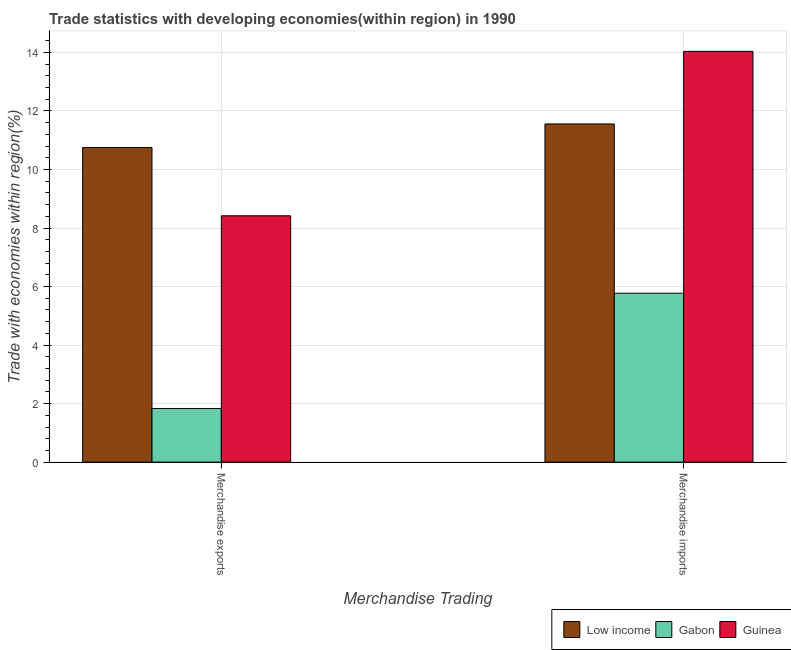How many groups of bars are there?
Provide a short and direct response. 2. Are the number of bars on each tick of the X-axis equal?
Give a very brief answer. Yes. How many bars are there on the 2nd tick from the right?
Provide a short and direct response. 3. What is the label of the 1st group of bars from the left?
Your answer should be compact. Merchandise exports. What is the merchandise imports in Guinea?
Your response must be concise. 14.04. Across all countries, what is the maximum merchandise imports?
Provide a short and direct response. 14.04. Across all countries, what is the minimum merchandise imports?
Give a very brief answer. 5.77. In which country was the merchandise exports maximum?
Provide a succinct answer. Low income. In which country was the merchandise imports minimum?
Your response must be concise. Gabon. What is the total merchandise imports in the graph?
Ensure brevity in your answer.  31.37. What is the difference between the merchandise exports in Guinea and that in Low income?
Offer a very short reply. -2.33. What is the difference between the merchandise exports in Low income and the merchandise imports in Guinea?
Provide a short and direct response. -3.28. What is the average merchandise exports per country?
Your answer should be compact. 7. What is the difference between the merchandise exports and merchandise imports in Guinea?
Provide a succinct answer. -5.62. In how many countries, is the merchandise exports greater than 2.8 %?
Offer a very short reply. 2. What is the ratio of the merchandise exports in Guinea to that in Gabon?
Keep it short and to the point. 4.59. Is the merchandise exports in Guinea less than that in Gabon?
Ensure brevity in your answer.  No. In how many countries, is the merchandise imports greater than the average merchandise imports taken over all countries?
Ensure brevity in your answer.  2. What does the 3rd bar from the left in Merchandise imports represents?
Provide a succinct answer. Guinea. What does the 1st bar from the right in Merchandise exports represents?
Ensure brevity in your answer.  Guinea. How many bars are there?
Make the answer very short. 6. Are all the bars in the graph horizontal?
Your answer should be very brief. No. What is the difference between two consecutive major ticks on the Y-axis?
Your answer should be very brief. 2. Where does the legend appear in the graph?
Offer a terse response. Bottom right. How many legend labels are there?
Give a very brief answer. 3. How are the legend labels stacked?
Provide a succinct answer. Horizontal. What is the title of the graph?
Give a very brief answer. Trade statistics with developing economies(within region) in 1990. Does "Uzbekistan" appear as one of the legend labels in the graph?
Offer a very short reply. No. What is the label or title of the X-axis?
Ensure brevity in your answer.  Merchandise Trading. What is the label or title of the Y-axis?
Offer a very short reply. Trade with economies within region(%). What is the Trade with economies within region(%) in Low income in Merchandise exports?
Provide a short and direct response. 10.75. What is the Trade with economies within region(%) in Gabon in Merchandise exports?
Your answer should be compact. 1.83. What is the Trade with economies within region(%) of Guinea in Merchandise exports?
Offer a very short reply. 8.42. What is the Trade with economies within region(%) in Low income in Merchandise imports?
Give a very brief answer. 11.56. What is the Trade with economies within region(%) of Gabon in Merchandise imports?
Keep it short and to the point. 5.77. What is the Trade with economies within region(%) of Guinea in Merchandise imports?
Your answer should be very brief. 14.04. Across all Merchandise Trading, what is the maximum Trade with economies within region(%) in Low income?
Provide a succinct answer. 11.56. Across all Merchandise Trading, what is the maximum Trade with economies within region(%) of Gabon?
Give a very brief answer. 5.77. Across all Merchandise Trading, what is the maximum Trade with economies within region(%) in Guinea?
Your answer should be compact. 14.04. Across all Merchandise Trading, what is the minimum Trade with economies within region(%) in Low income?
Provide a succinct answer. 10.75. Across all Merchandise Trading, what is the minimum Trade with economies within region(%) in Gabon?
Make the answer very short. 1.83. Across all Merchandise Trading, what is the minimum Trade with economies within region(%) of Guinea?
Make the answer very short. 8.42. What is the total Trade with economies within region(%) of Low income in the graph?
Offer a very short reply. 22.31. What is the total Trade with economies within region(%) of Gabon in the graph?
Offer a very short reply. 7.61. What is the total Trade with economies within region(%) in Guinea in the graph?
Ensure brevity in your answer.  22.46. What is the difference between the Trade with economies within region(%) in Low income in Merchandise exports and that in Merchandise imports?
Your response must be concise. -0.8. What is the difference between the Trade with economies within region(%) of Gabon in Merchandise exports and that in Merchandise imports?
Give a very brief answer. -3.94. What is the difference between the Trade with economies within region(%) of Guinea in Merchandise exports and that in Merchandise imports?
Offer a terse response. -5.62. What is the difference between the Trade with economies within region(%) in Low income in Merchandise exports and the Trade with economies within region(%) in Gabon in Merchandise imports?
Provide a succinct answer. 4.98. What is the difference between the Trade with economies within region(%) of Low income in Merchandise exports and the Trade with economies within region(%) of Guinea in Merchandise imports?
Make the answer very short. -3.28. What is the difference between the Trade with economies within region(%) in Gabon in Merchandise exports and the Trade with economies within region(%) in Guinea in Merchandise imports?
Provide a succinct answer. -12.2. What is the average Trade with economies within region(%) of Low income per Merchandise Trading?
Your response must be concise. 11.15. What is the average Trade with economies within region(%) in Gabon per Merchandise Trading?
Your answer should be very brief. 3.8. What is the average Trade with economies within region(%) of Guinea per Merchandise Trading?
Keep it short and to the point. 11.23. What is the difference between the Trade with economies within region(%) in Low income and Trade with economies within region(%) in Gabon in Merchandise exports?
Make the answer very short. 8.92. What is the difference between the Trade with economies within region(%) in Low income and Trade with economies within region(%) in Guinea in Merchandise exports?
Your answer should be very brief. 2.33. What is the difference between the Trade with economies within region(%) in Gabon and Trade with economies within region(%) in Guinea in Merchandise exports?
Provide a succinct answer. -6.59. What is the difference between the Trade with economies within region(%) of Low income and Trade with economies within region(%) of Gabon in Merchandise imports?
Your answer should be compact. 5.78. What is the difference between the Trade with economies within region(%) of Low income and Trade with economies within region(%) of Guinea in Merchandise imports?
Make the answer very short. -2.48. What is the difference between the Trade with economies within region(%) of Gabon and Trade with economies within region(%) of Guinea in Merchandise imports?
Keep it short and to the point. -8.26. What is the ratio of the Trade with economies within region(%) of Low income in Merchandise exports to that in Merchandise imports?
Give a very brief answer. 0.93. What is the ratio of the Trade with economies within region(%) in Gabon in Merchandise exports to that in Merchandise imports?
Offer a terse response. 0.32. What is the ratio of the Trade with economies within region(%) in Guinea in Merchandise exports to that in Merchandise imports?
Offer a terse response. 0.6. What is the difference between the highest and the second highest Trade with economies within region(%) of Low income?
Your answer should be compact. 0.8. What is the difference between the highest and the second highest Trade with economies within region(%) of Gabon?
Your answer should be very brief. 3.94. What is the difference between the highest and the second highest Trade with economies within region(%) in Guinea?
Ensure brevity in your answer.  5.62. What is the difference between the highest and the lowest Trade with economies within region(%) in Low income?
Make the answer very short. 0.8. What is the difference between the highest and the lowest Trade with economies within region(%) of Gabon?
Provide a succinct answer. 3.94. What is the difference between the highest and the lowest Trade with economies within region(%) in Guinea?
Give a very brief answer. 5.62. 